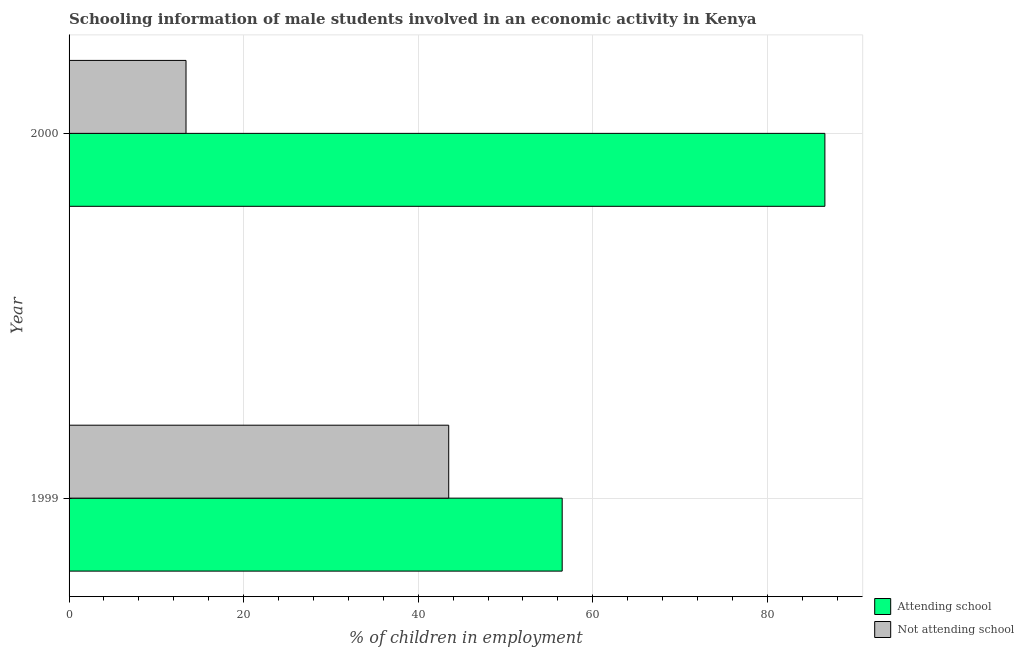How many different coloured bars are there?
Keep it short and to the point. 2. Are the number of bars on each tick of the Y-axis equal?
Give a very brief answer. Yes. What is the percentage of employed males who are not attending school in 1999?
Provide a short and direct response. 43.5. Across all years, what is the maximum percentage of employed males who are attending school?
Provide a succinct answer. 86.6. Across all years, what is the minimum percentage of employed males who are attending school?
Your response must be concise. 56.5. In which year was the percentage of employed males who are attending school maximum?
Your answer should be compact. 2000. What is the total percentage of employed males who are not attending school in the graph?
Your answer should be very brief. 56.9. What is the difference between the percentage of employed males who are attending school in 1999 and that in 2000?
Give a very brief answer. -30.1. What is the difference between the percentage of employed males who are attending school in 2000 and the percentage of employed males who are not attending school in 1999?
Give a very brief answer. 43.1. What is the average percentage of employed males who are attending school per year?
Keep it short and to the point. 71.55. In the year 2000, what is the difference between the percentage of employed males who are not attending school and percentage of employed males who are attending school?
Your answer should be compact. -73.2. What is the ratio of the percentage of employed males who are not attending school in 1999 to that in 2000?
Ensure brevity in your answer.  3.25. What does the 2nd bar from the top in 1999 represents?
Your response must be concise. Attending school. What does the 2nd bar from the bottom in 2000 represents?
Your response must be concise. Not attending school. How many bars are there?
Give a very brief answer. 4. Are all the bars in the graph horizontal?
Give a very brief answer. Yes. What is the difference between two consecutive major ticks on the X-axis?
Your answer should be very brief. 20. Does the graph contain any zero values?
Provide a succinct answer. No. How many legend labels are there?
Ensure brevity in your answer.  2. How are the legend labels stacked?
Provide a succinct answer. Vertical. What is the title of the graph?
Ensure brevity in your answer.  Schooling information of male students involved in an economic activity in Kenya. Does "Nitrous oxide emissions" appear as one of the legend labels in the graph?
Provide a short and direct response. No. What is the label or title of the X-axis?
Your answer should be compact. % of children in employment. What is the % of children in employment in Attending school in 1999?
Ensure brevity in your answer.  56.5. What is the % of children in employment in Not attending school in 1999?
Your response must be concise. 43.5. What is the % of children in employment in Attending school in 2000?
Keep it short and to the point. 86.6. What is the % of children in employment of Not attending school in 2000?
Ensure brevity in your answer.  13.4. Across all years, what is the maximum % of children in employment of Attending school?
Make the answer very short. 86.6. Across all years, what is the maximum % of children in employment of Not attending school?
Offer a terse response. 43.5. Across all years, what is the minimum % of children in employment of Attending school?
Offer a terse response. 56.5. What is the total % of children in employment in Attending school in the graph?
Provide a succinct answer. 143.1. What is the total % of children in employment of Not attending school in the graph?
Your response must be concise. 56.9. What is the difference between the % of children in employment of Attending school in 1999 and that in 2000?
Make the answer very short. -30.1. What is the difference between the % of children in employment of Not attending school in 1999 and that in 2000?
Your response must be concise. 30.1. What is the difference between the % of children in employment of Attending school in 1999 and the % of children in employment of Not attending school in 2000?
Offer a terse response. 43.1. What is the average % of children in employment of Attending school per year?
Make the answer very short. 71.55. What is the average % of children in employment in Not attending school per year?
Make the answer very short. 28.45. In the year 1999, what is the difference between the % of children in employment of Attending school and % of children in employment of Not attending school?
Your answer should be compact. 13. In the year 2000, what is the difference between the % of children in employment in Attending school and % of children in employment in Not attending school?
Provide a short and direct response. 73.2. What is the ratio of the % of children in employment of Attending school in 1999 to that in 2000?
Provide a succinct answer. 0.65. What is the ratio of the % of children in employment of Not attending school in 1999 to that in 2000?
Ensure brevity in your answer.  3.25. What is the difference between the highest and the second highest % of children in employment of Attending school?
Give a very brief answer. 30.1. What is the difference between the highest and the second highest % of children in employment in Not attending school?
Keep it short and to the point. 30.1. What is the difference between the highest and the lowest % of children in employment of Attending school?
Make the answer very short. 30.1. What is the difference between the highest and the lowest % of children in employment in Not attending school?
Your response must be concise. 30.1. 